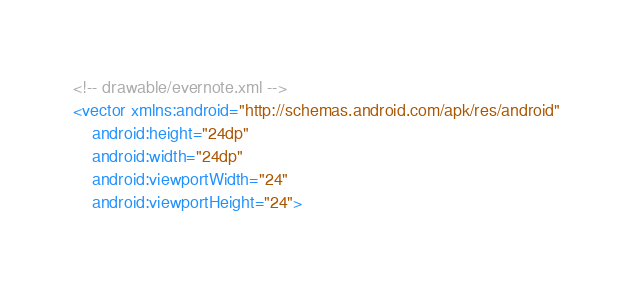<code> <loc_0><loc_0><loc_500><loc_500><_XML_><!-- drawable/evernote.xml -->
<vector xmlns:android="http://schemas.android.com/apk/res/android"
    android:height="24dp"
    android:width="24dp"
    android:viewportWidth="24"
    android:viewportHeight="24"></code> 